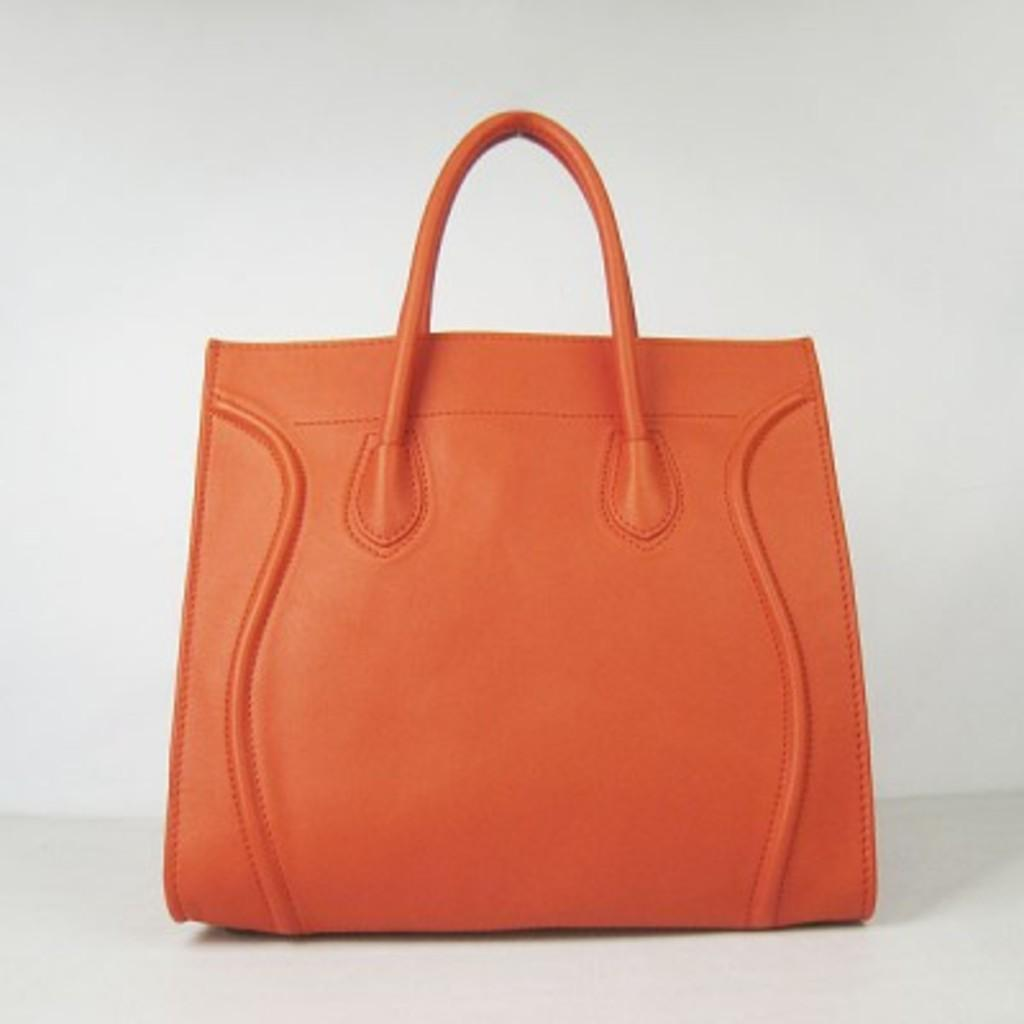What object is the main focus of the image? There is a handbag in the image. Can you describe the color of the handbag? The handbag is orange in color. What can be seen in the background of the image? The background of the image is white. How many dust particles can be seen on the handbag in the image? There is no mention of dust particles in the image, so it is not possible to determine their number. What type of pan is being used to cook in the image? There is no pan present in the image; it features a handbag. 